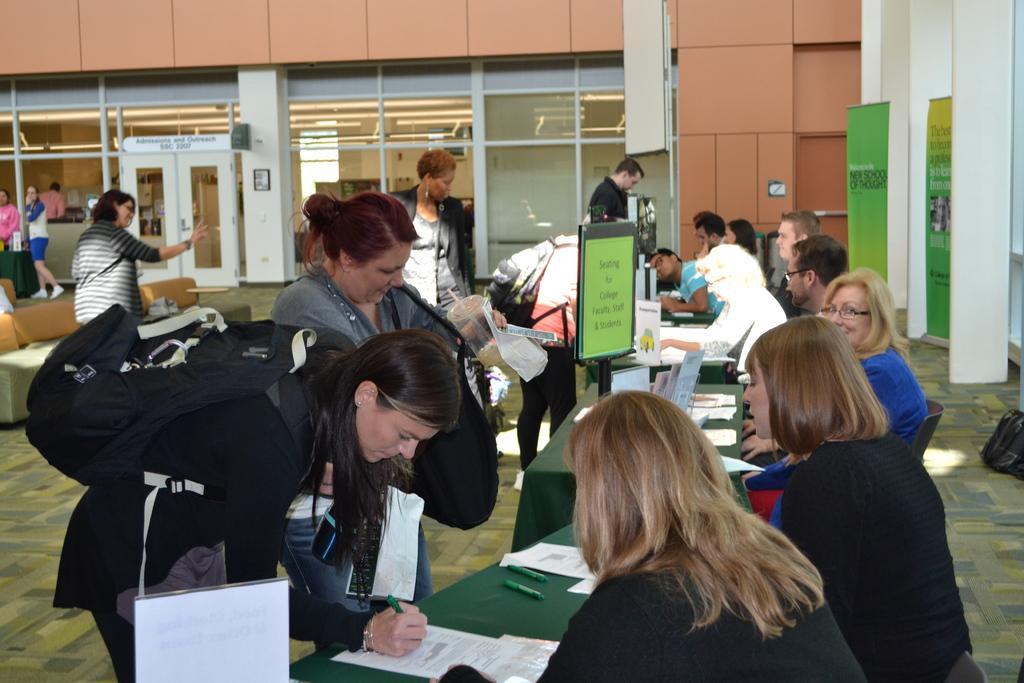Describe this image in one or two sentences. On the left side of the image we can see a lady standing and waving her hand and a lady is blending and filling a form. In the middle of the image we can see a table, a board and some persons are standing. On the right side of the image we can see some persons are sitting on the chairs and some posters are there. 